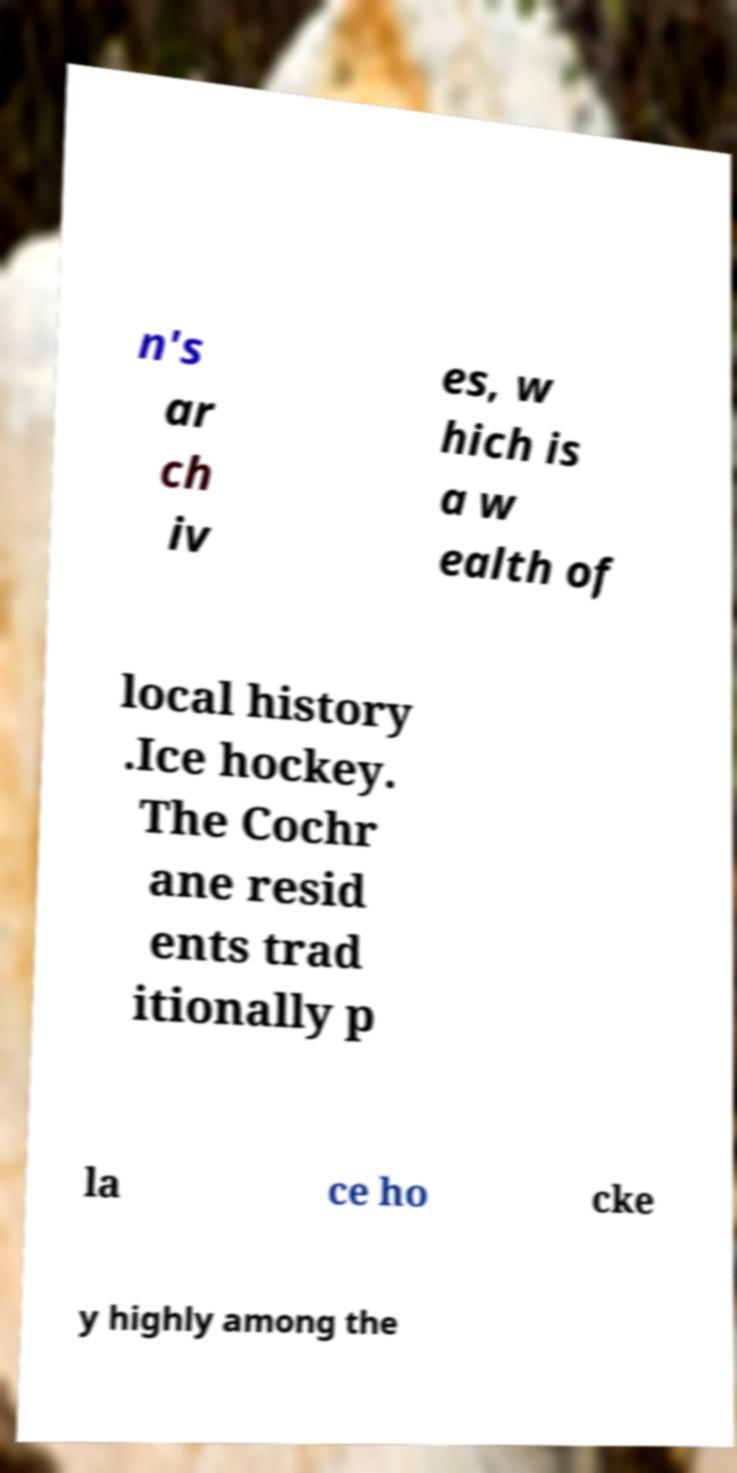Could you extract and type out the text from this image? n's ar ch iv es, w hich is a w ealth of local history .Ice hockey. The Cochr ane resid ents trad itionally p la ce ho cke y highly among the 